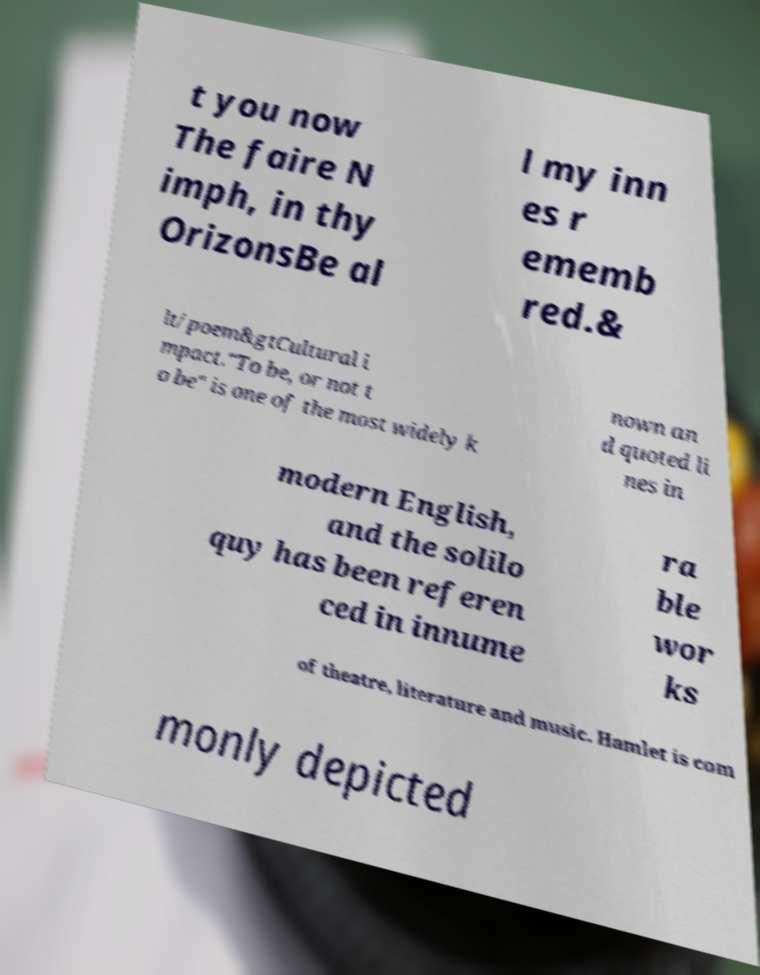Can you read and provide the text displayed in the image?This photo seems to have some interesting text. Can you extract and type it out for me? t you now The faire N imph, in thy OrizonsBe al l my inn es r ememb red.& lt/poem&gtCultural i mpact."To be, or not t o be" is one of the most widely k nown an d quoted li nes in modern English, and the solilo quy has been referen ced in innume ra ble wor ks of theatre, literature and music. Hamlet is com monly depicted 